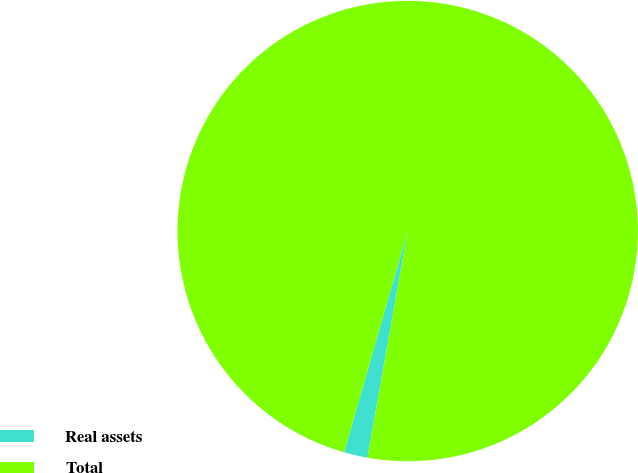Convert chart. <chart><loc_0><loc_0><loc_500><loc_500><pie_chart><fcel>Real assets<fcel>Total<nl><fcel>1.66%<fcel>98.34%<nl></chart> 